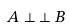<formula> <loc_0><loc_0><loc_500><loc_500>A \perp \, \perp B</formula> 